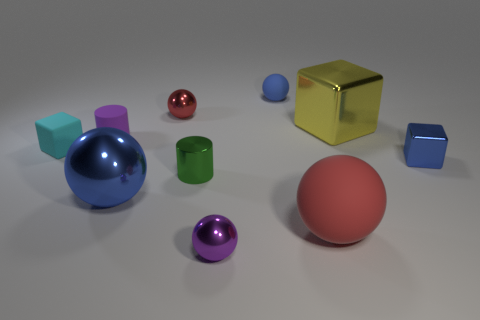There is a red thing behind the cyan matte cube; is its size the same as the green shiny cylinder?
Offer a terse response. Yes. There is a big blue metal thing; what shape is it?
Make the answer very short. Sphere. What is the size of the metal sphere that is the same color as the tiny matte ball?
Offer a very short reply. Large. Is the blue ball behind the big yellow shiny object made of the same material as the big yellow object?
Provide a short and direct response. No. Are there any metallic things of the same color as the small matte cylinder?
Provide a short and direct response. Yes. There is a blue thing in front of the small shiny cylinder; is its shape the same as the object on the left side of the small purple matte cylinder?
Make the answer very short. No. Is there a big yellow cylinder made of the same material as the tiny green thing?
Make the answer very short. No. How many purple objects are large metallic blocks or metallic cylinders?
Give a very brief answer. 0. How big is the rubber thing that is both in front of the tiny purple cylinder and right of the rubber block?
Keep it short and to the point. Large. Is the number of objects that are behind the small red sphere greater than the number of big blue shiny blocks?
Keep it short and to the point. Yes. 